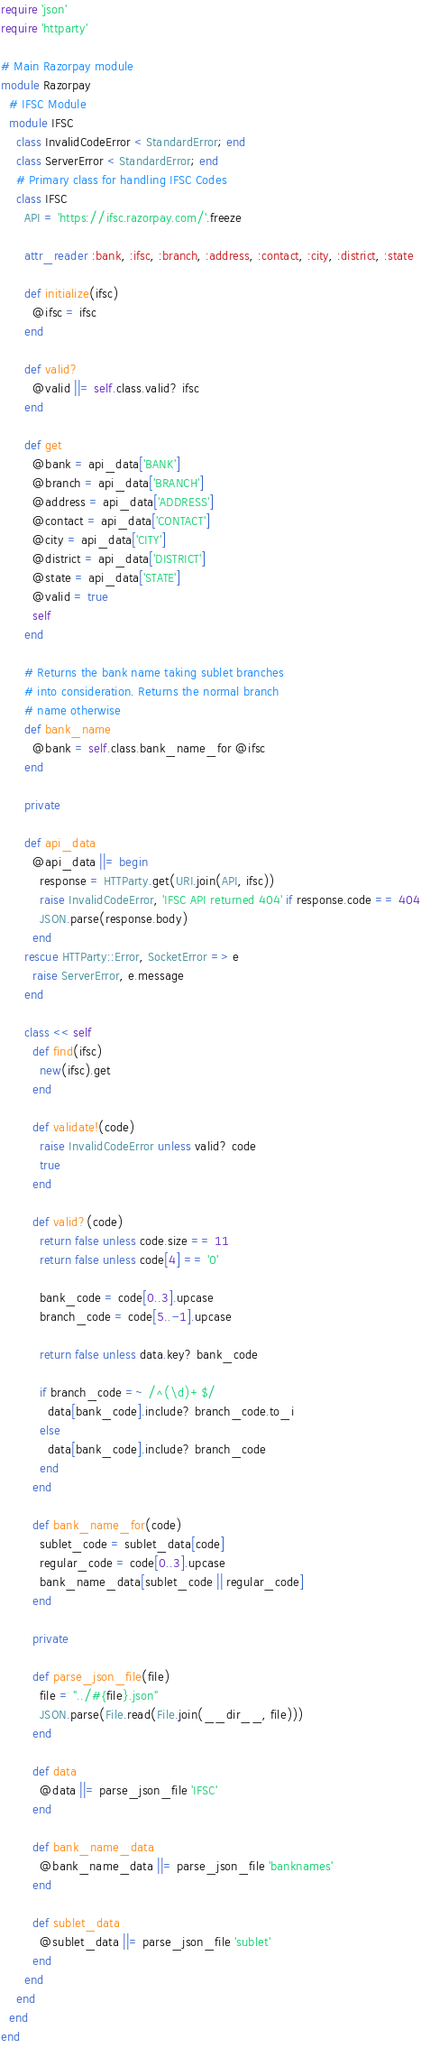<code> <loc_0><loc_0><loc_500><loc_500><_Ruby_>require 'json'
require 'httparty'

# Main Razorpay module
module Razorpay
  # IFSC Module
  module IFSC
    class InvalidCodeError < StandardError; end
    class ServerError < StandardError; end
    # Primary class for handling IFSC Codes
    class IFSC
      API = 'https://ifsc.razorpay.com/'.freeze

      attr_reader :bank, :ifsc, :branch, :address, :contact, :city, :district, :state

      def initialize(ifsc)
        @ifsc = ifsc
      end

      def valid?
        @valid ||= self.class.valid? ifsc
      end

      def get
        @bank = api_data['BANK']
        @branch = api_data['BRANCH']
        @address = api_data['ADDRESS']
        @contact = api_data['CONTACT']
        @city = api_data['CITY']
        @district = api_data['DISTRICT']
        @state = api_data['STATE']
        @valid = true
        self
      end

      # Returns the bank name taking sublet branches
      # into consideration. Returns the normal branch
      # name otherwise
      def bank_name
        @bank = self.class.bank_name_for @ifsc
      end

      private

      def api_data
        @api_data ||= begin
          response = HTTParty.get(URI.join(API, ifsc))
          raise InvalidCodeError, 'IFSC API returned 404' if response.code == 404
          JSON.parse(response.body)
        end
      rescue HTTParty::Error, SocketError => e
        raise ServerError, e.message
      end

      class << self
        def find(ifsc)
          new(ifsc).get
        end

        def validate!(code)
          raise InvalidCodeError unless valid? code
          true
        end

        def valid?(code)
          return false unless code.size == 11
          return false unless code[4] == '0'

          bank_code = code[0..3].upcase
          branch_code = code[5..-1].upcase

          return false unless data.key? bank_code

          if branch_code =~ /^(\d)+$/
            data[bank_code].include? branch_code.to_i
          else
            data[bank_code].include? branch_code
          end
        end

        def bank_name_for(code)
          sublet_code = sublet_data[code]
          regular_code = code[0..3].upcase
          bank_name_data[sublet_code || regular_code]
        end

        private

        def parse_json_file(file)
          file = "../#{file}.json"
          JSON.parse(File.read(File.join(__dir__, file)))
        end

        def data
          @data ||= parse_json_file 'IFSC'
        end

        def bank_name_data
          @bank_name_data ||= parse_json_file 'banknames'
        end

        def sublet_data
          @sublet_data ||= parse_json_file 'sublet'
        end
      end
    end
  end
end
</code> 